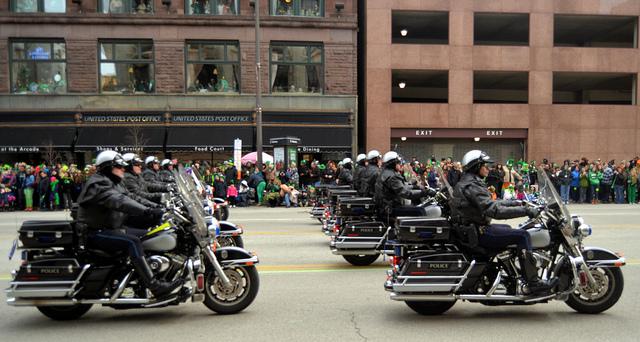Are the police wearing helmets?
Answer briefly. Yes. What kind of vehicle are the policemen driving?
Write a very short answer. Motorcycles. Are the officers in a parade?
Concise answer only. Yes. How many police officers are in this scene?
Be succinct. 10. 